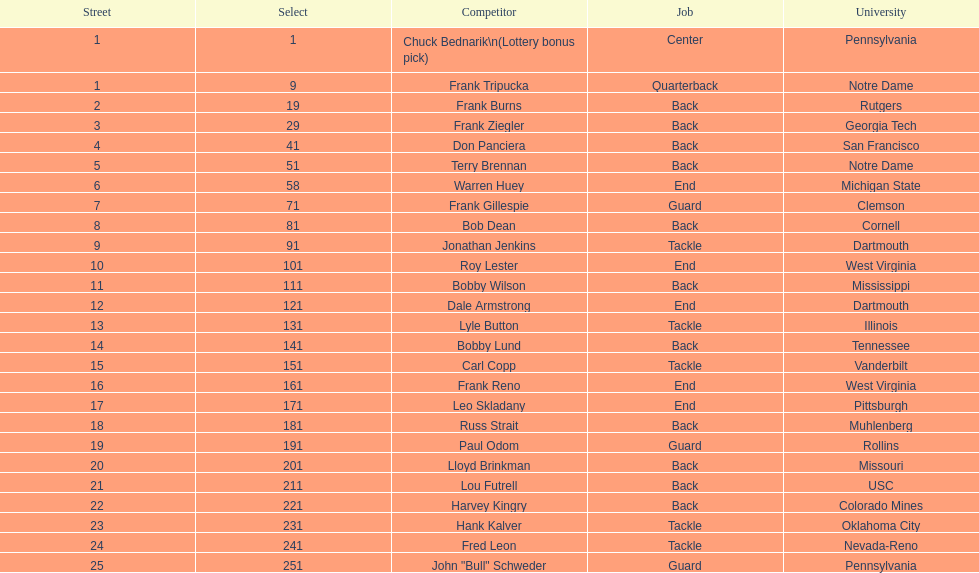Could you parse the entire table? {'header': ['Street', 'Select', 'Competitor', 'Job', 'University'], 'rows': [['1', '1', 'Chuck Bednarik\\n(Lottery bonus pick)', 'Center', 'Pennsylvania'], ['1', '9', 'Frank Tripucka', 'Quarterback', 'Notre Dame'], ['2', '19', 'Frank Burns', 'Back', 'Rutgers'], ['3', '29', 'Frank Ziegler', 'Back', 'Georgia Tech'], ['4', '41', 'Don Panciera', 'Back', 'San Francisco'], ['5', '51', 'Terry Brennan', 'Back', 'Notre Dame'], ['6', '58', 'Warren Huey', 'End', 'Michigan State'], ['7', '71', 'Frank Gillespie', 'Guard', 'Clemson'], ['8', '81', 'Bob Dean', 'Back', 'Cornell'], ['9', '91', 'Jonathan Jenkins', 'Tackle', 'Dartmouth'], ['10', '101', 'Roy Lester', 'End', 'West Virginia'], ['11', '111', 'Bobby Wilson', 'Back', 'Mississippi'], ['12', '121', 'Dale Armstrong', 'End', 'Dartmouth'], ['13', '131', 'Lyle Button', 'Tackle', 'Illinois'], ['14', '141', 'Bobby Lund', 'Back', 'Tennessee'], ['15', '151', 'Carl Copp', 'Tackle', 'Vanderbilt'], ['16', '161', 'Frank Reno', 'End', 'West Virginia'], ['17', '171', 'Leo Skladany', 'End', 'Pittsburgh'], ['18', '181', 'Russ Strait', 'Back', 'Muhlenberg'], ['19', '191', 'Paul Odom', 'Guard', 'Rollins'], ['20', '201', 'Lloyd Brinkman', 'Back', 'Missouri'], ['21', '211', 'Lou Futrell', 'Back', 'USC'], ['22', '221', 'Harvey Kingry', 'Back', 'Colorado Mines'], ['23', '231', 'Hank Kalver', 'Tackle', 'Oklahoma City'], ['24', '241', 'Fred Leon', 'Tackle', 'Nevada-Reno'], ['25', '251', 'John "Bull" Schweder', 'Guard', 'Pennsylvania']]} Who was the player that the team drafted after bob dean? Jonathan Jenkins. 